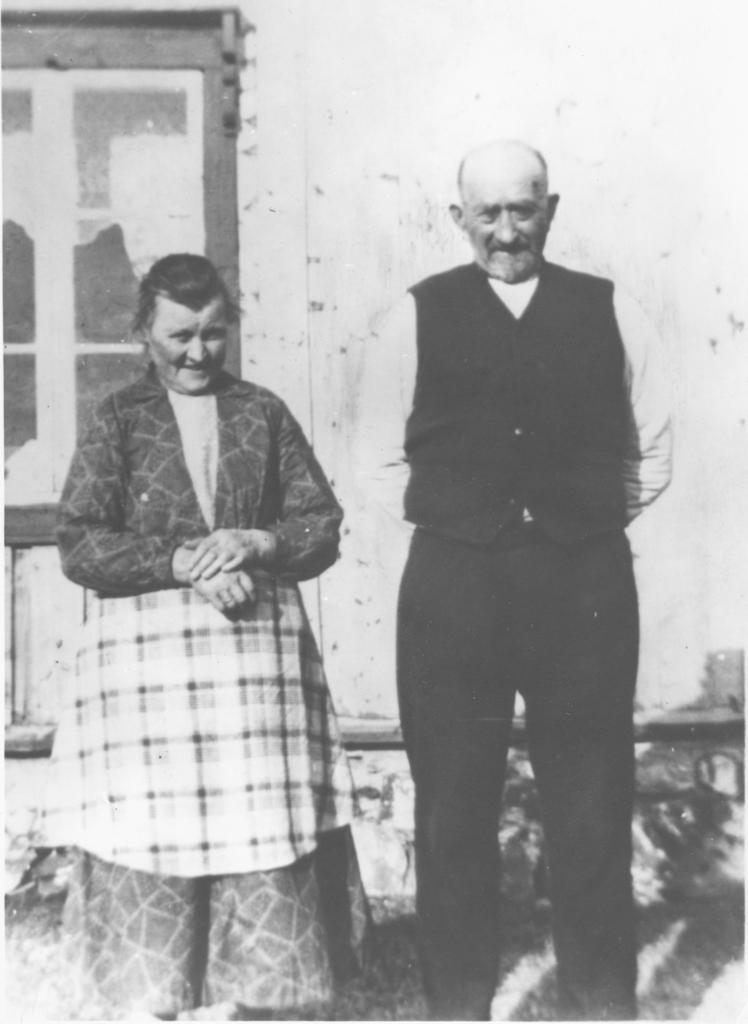What is the color scheme of the image? The image is black and white. How many people are present in the image? There are 2 people standing in the image. What can be seen in the background of the image? There is a building in the background of the image. What feature of the building is mentioned in the facts? The building has a window. What type of drink is being served in the image? There is no drink present in the image. Can you see a snake in the image? There is no snake present in the image. 